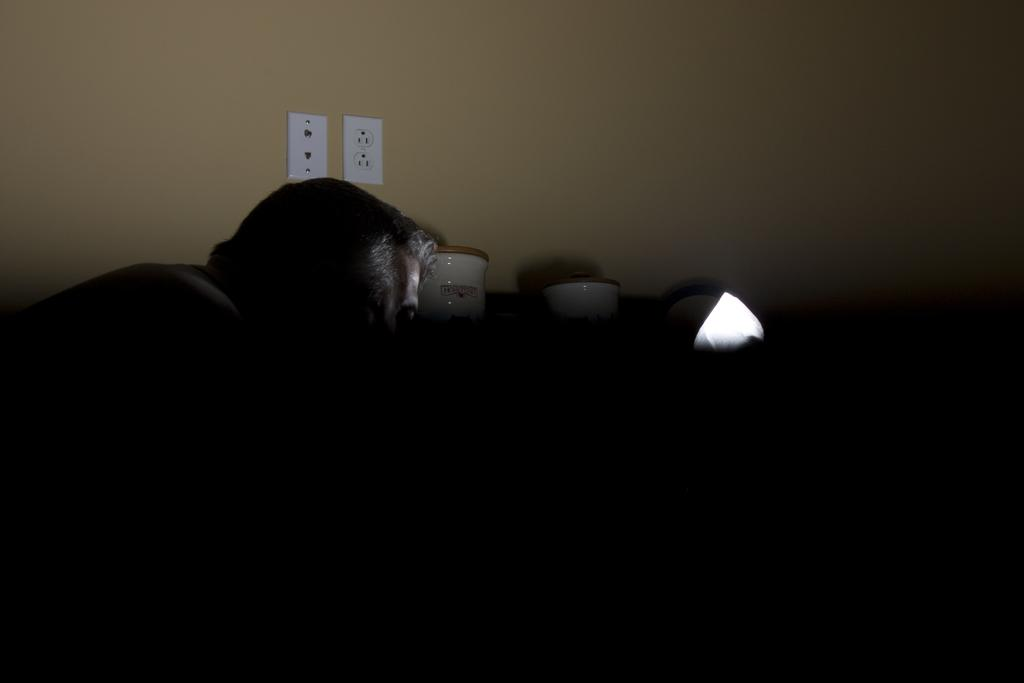Who or what is present in the image? There is a person in the image. What can be seen in the background of the image? There is a wall in the background of the image. What feature is present on the wall? The wall has sockets on it. What color are some of the objects in the image? There are white color objects in the image. How would you describe the overall lighting in the image? The image is dark. How does the person in the image feel about the fly buzzing around them? There is no fly present in the image, so it is not possible to determine how the person feels about it. 